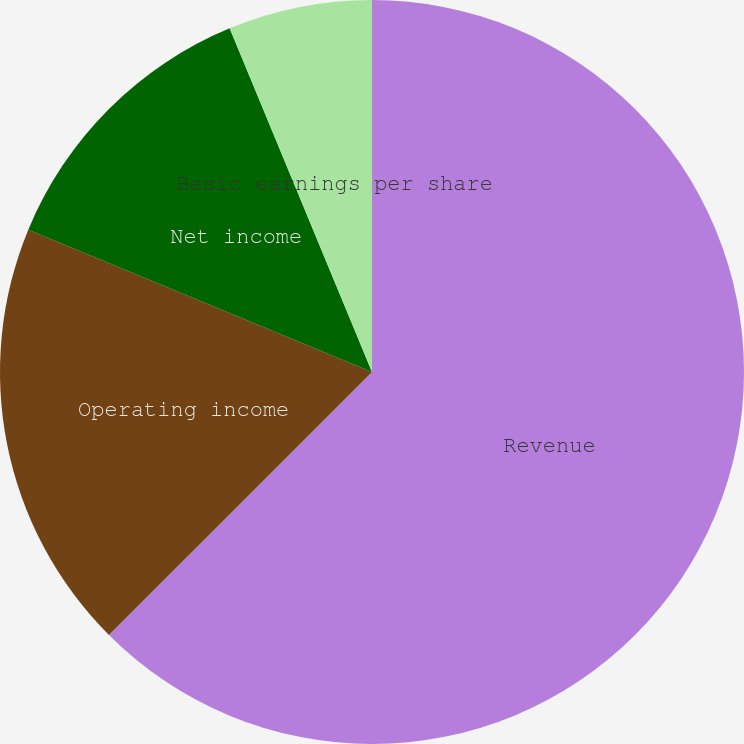<chart> <loc_0><loc_0><loc_500><loc_500><pie_chart><fcel>Revenue<fcel>Operating income<fcel>Net income<fcel>Basic earnings per share<fcel>Diluted earnings per share<nl><fcel>62.5%<fcel>18.75%<fcel>12.5%<fcel>6.25%<fcel>0.0%<nl></chart> 